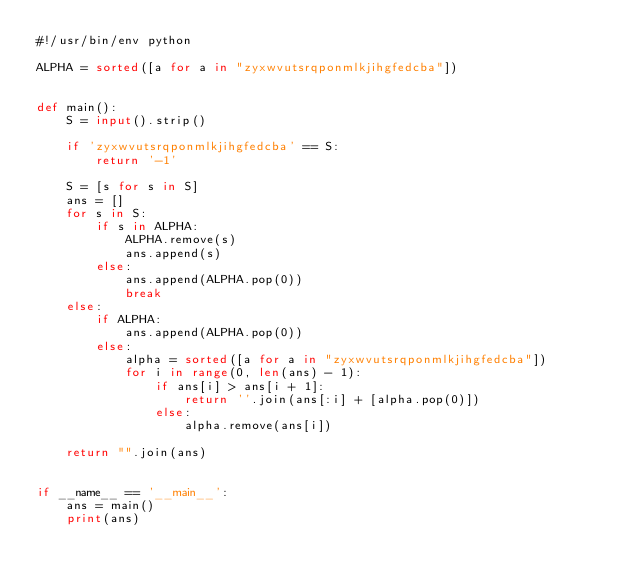Convert code to text. <code><loc_0><loc_0><loc_500><loc_500><_Python_>#!/usr/bin/env python

ALPHA = sorted([a for a in "zyxwvutsrqponmlkjihgfedcba"])


def main():
    S = input().strip()

    if 'zyxwvutsrqponmlkjihgfedcba' == S:
        return '-1'

    S = [s for s in S]
    ans = []
    for s in S:
        if s in ALPHA:
            ALPHA.remove(s)
            ans.append(s)
        else:
            ans.append(ALPHA.pop(0))
            break
    else:
        if ALPHA:
            ans.append(ALPHA.pop(0))
        else:
            alpha = sorted([a for a in "zyxwvutsrqponmlkjihgfedcba"])
            for i in range(0, len(ans) - 1):
                if ans[i] > ans[i + 1]:
                    return ''.join(ans[:i] + [alpha.pop(0)])
                else:
                    alpha.remove(ans[i])

    return "".join(ans)


if __name__ == '__main__':
    ans = main()
    print(ans)</code> 